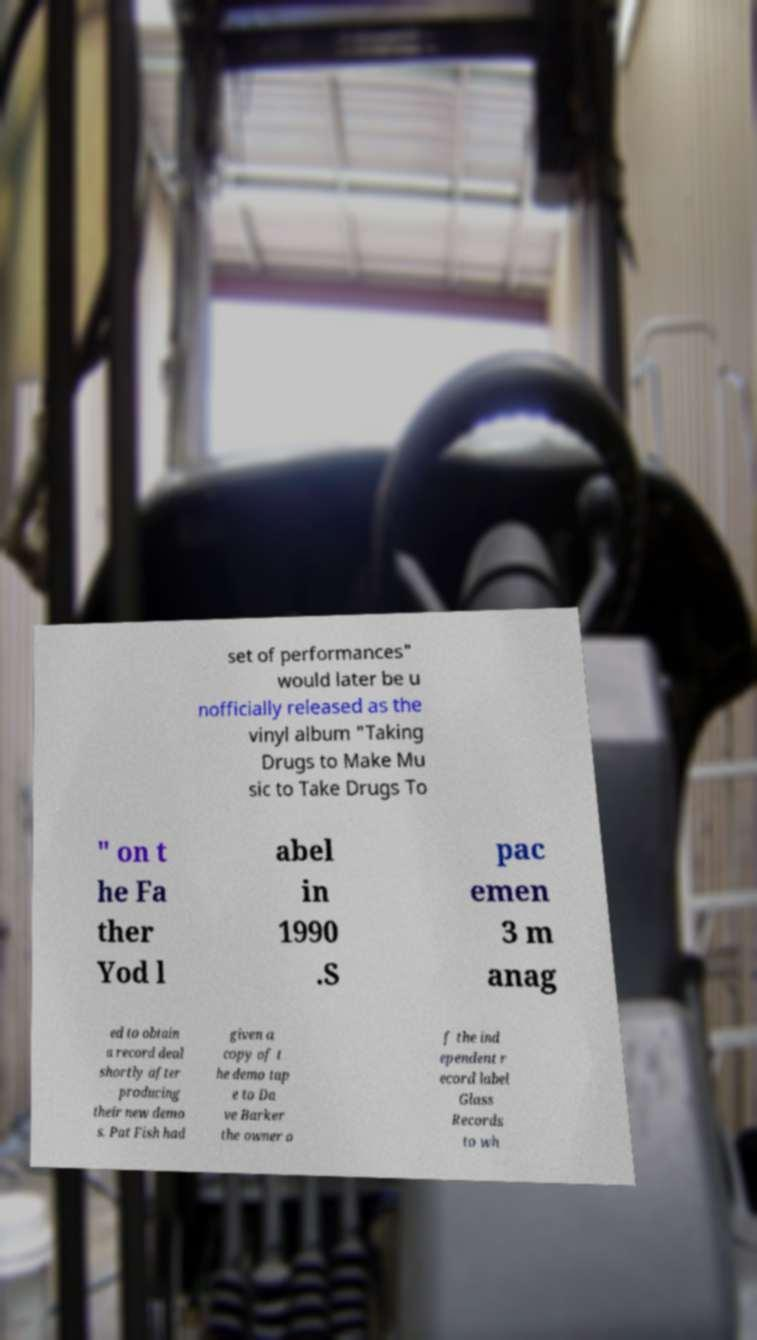Can you accurately transcribe the text from the provided image for me? set of performances" would later be u nofficially released as the vinyl album "Taking Drugs to Make Mu sic to Take Drugs To " on t he Fa ther Yod l abel in 1990 .S pac emen 3 m anag ed to obtain a record deal shortly after producing their new demo s. Pat Fish had given a copy of t he demo tap e to Da ve Barker the owner o f the ind ependent r ecord label Glass Records to wh 